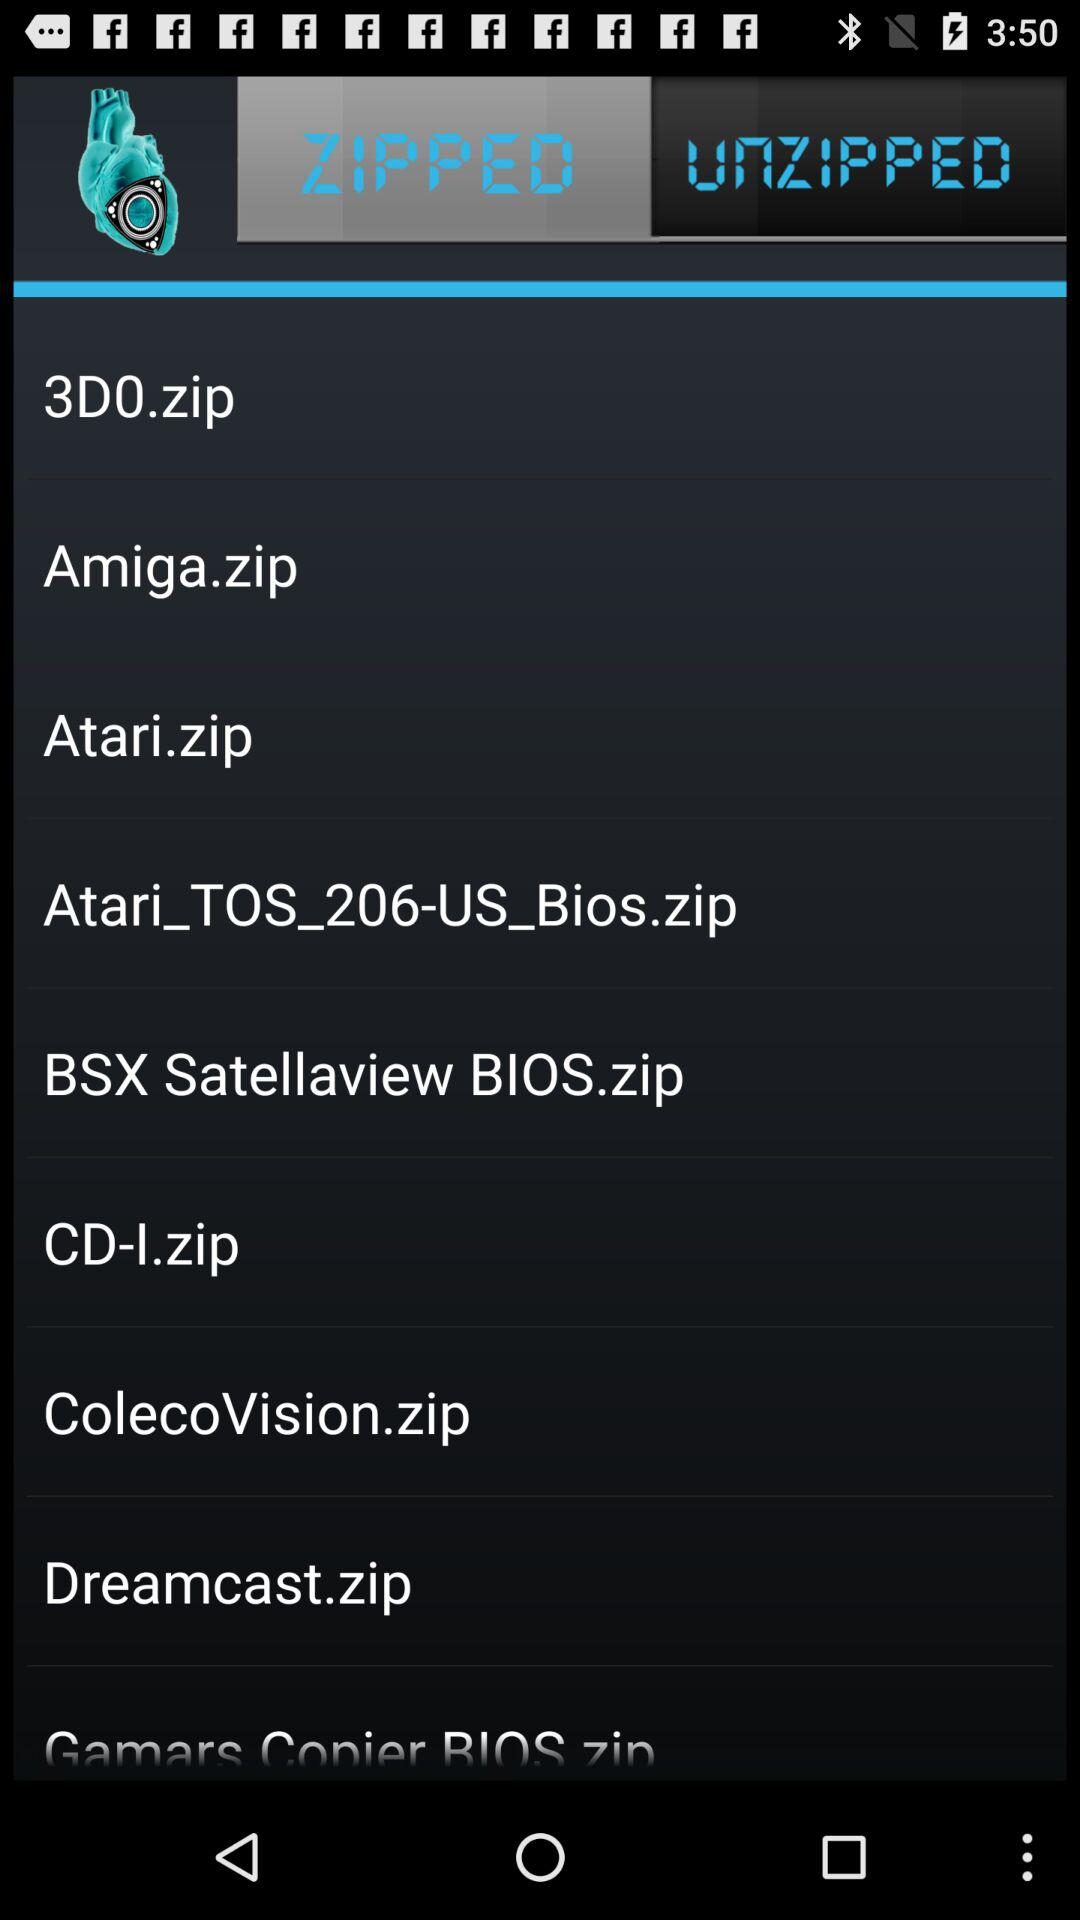Which files are unzipped?
When the provided information is insufficient, respond with <no answer>. <no answer> 